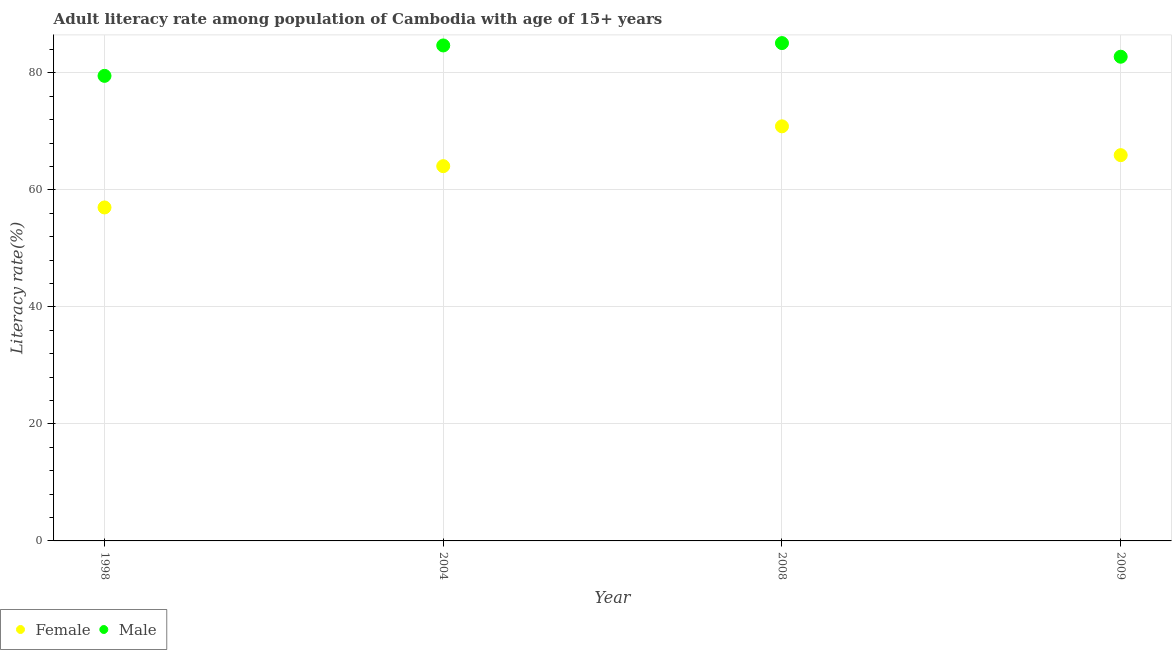How many different coloured dotlines are there?
Ensure brevity in your answer.  2. What is the male adult literacy rate in 2008?
Provide a short and direct response. 85.08. Across all years, what is the maximum male adult literacy rate?
Your answer should be very brief. 85.08. Across all years, what is the minimum male adult literacy rate?
Provide a short and direct response. 79.48. In which year was the female adult literacy rate maximum?
Offer a very short reply. 2008. In which year was the female adult literacy rate minimum?
Offer a terse response. 1998. What is the total female adult literacy rate in the graph?
Your answer should be very brief. 257.83. What is the difference between the female adult literacy rate in 1998 and that in 2008?
Keep it short and to the point. -13.87. What is the difference between the male adult literacy rate in 2004 and the female adult literacy rate in 2008?
Your response must be concise. 13.82. What is the average female adult literacy rate per year?
Make the answer very short. 64.46. In the year 2008, what is the difference between the male adult literacy rate and female adult literacy rate?
Keep it short and to the point. 14.22. In how many years, is the male adult literacy rate greater than 16 %?
Ensure brevity in your answer.  4. What is the ratio of the male adult literacy rate in 2004 to that in 2009?
Your response must be concise. 1.02. Is the female adult literacy rate in 1998 less than that in 2009?
Make the answer very short. Yes. Is the difference between the female adult literacy rate in 2004 and 2009 greater than the difference between the male adult literacy rate in 2004 and 2009?
Offer a terse response. No. What is the difference between the highest and the second highest male adult literacy rate?
Keep it short and to the point. 0.4. What is the difference between the highest and the lowest female adult literacy rate?
Your response must be concise. 13.87. In how many years, is the female adult literacy rate greater than the average female adult literacy rate taken over all years?
Offer a very short reply. 2. Is the sum of the female adult literacy rate in 1998 and 2009 greater than the maximum male adult literacy rate across all years?
Offer a very short reply. Yes. Does the female adult literacy rate monotonically increase over the years?
Offer a terse response. No. Is the male adult literacy rate strictly greater than the female adult literacy rate over the years?
Give a very brief answer. Yes. How many years are there in the graph?
Your answer should be compact. 4. What is the difference between two consecutive major ticks on the Y-axis?
Provide a short and direct response. 20. Does the graph contain any zero values?
Ensure brevity in your answer.  No. Does the graph contain grids?
Provide a short and direct response. Yes. How many legend labels are there?
Your answer should be compact. 2. What is the title of the graph?
Your answer should be very brief. Adult literacy rate among population of Cambodia with age of 15+ years. What is the label or title of the X-axis?
Offer a very short reply. Year. What is the label or title of the Y-axis?
Your answer should be very brief. Literacy rate(%). What is the Literacy rate(%) of Female in 1998?
Offer a terse response. 56.99. What is the Literacy rate(%) in Male in 1998?
Your response must be concise. 79.48. What is the Literacy rate(%) in Female in 2004?
Keep it short and to the point. 64.05. What is the Literacy rate(%) of Male in 2004?
Ensure brevity in your answer.  84.68. What is the Literacy rate(%) in Female in 2008?
Offer a terse response. 70.86. What is the Literacy rate(%) of Male in 2008?
Provide a succinct answer. 85.08. What is the Literacy rate(%) in Female in 2009?
Give a very brief answer. 65.93. What is the Literacy rate(%) in Male in 2009?
Your answer should be compact. 82.75. Across all years, what is the maximum Literacy rate(%) of Female?
Offer a terse response. 70.86. Across all years, what is the maximum Literacy rate(%) of Male?
Your response must be concise. 85.08. Across all years, what is the minimum Literacy rate(%) in Female?
Offer a terse response. 56.99. Across all years, what is the minimum Literacy rate(%) of Male?
Give a very brief answer. 79.48. What is the total Literacy rate(%) of Female in the graph?
Offer a very short reply. 257.83. What is the total Literacy rate(%) of Male in the graph?
Offer a very short reply. 332. What is the difference between the Literacy rate(%) in Female in 1998 and that in 2004?
Your response must be concise. -7.06. What is the difference between the Literacy rate(%) of Male in 1998 and that in 2004?
Your answer should be very brief. -5.2. What is the difference between the Literacy rate(%) in Female in 1998 and that in 2008?
Keep it short and to the point. -13.87. What is the difference between the Literacy rate(%) of Male in 1998 and that in 2008?
Your answer should be compact. -5.6. What is the difference between the Literacy rate(%) of Female in 1998 and that in 2009?
Your answer should be very brief. -8.94. What is the difference between the Literacy rate(%) in Male in 1998 and that in 2009?
Provide a short and direct response. -3.27. What is the difference between the Literacy rate(%) in Female in 2004 and that in 2008?
Keep it short and to the point. -6.81. What is the difference between the Literacy rate(%) in Male in 2004 and that in 2008?
Ensure brevity in your answer.  -0.4. What is the difference between the Literacy rate(%) of Female in 2004 and that in 2009?
Make the answer very short. -1.88. What is the difference between the Literacy rate(%) of Male in 2004 and that in 2009?
Keep it short and to the point. 1.93. What is the difference between the Literacy rate(%) in Female in 2008 and that in 2009?
Your answer should be very brief. 4.93. What is the difference between the Literacy rate(%) in Male in 2008 and that in 2009?
Offer a very short reply. 2.33. What is the difference between the Literacy rate(%) in Female in 1998 and the Literacy rate(%) in Male in 2004?
Ensure brevity in your answer.  -27.69. What is the difference between the Literacy rate(%) of Female in 1998 and the Literacy rate(%) of Male in 2008?
Your response must be concise. -28.09. What is the difference between the Literacy rate(%) of Female in 1998 and the Literacy rate(%) of Male in 2009?
Ensure brevity in your answer.  -25.76. What is the difference between the Literacy rate(%) in Female in 2004 and the Literacy rate(%) in Male in 2008?
Ensure brevity in your answer.  -21.03. What is the difference between the Literacy rate(%) in Female in 2004 and the Literacy rate(%) in Male in 2009?
Give a very brief answer. -18.7. What is the difference between the Literacy rate(%) of Female in 2008 and the Literacy rate(%) of Male in 2009?
Your answer should be compact. -11.89. What is the average Literacy rate(%) of Female per year?
Ensure brevity in your answer.  64.46. What is the average Literacy rate(%) in Male per year?
Provide a short and direct response. 83. In the year 1998, what is the difference between the Literacy rate(%) in Female and Literacy rate(%) in Male?
Your answer should be compact. -22.49. In the year 2004, what is the difference between the Literacy rate(%) in Female and Literacy rate(%) in Male?
Your answer should be very brief. -20.63. In the year 2008, what is the difference between the Literacy rate(%) of Female and Literacy rate(%) of Male?
Your answer should be compact. -14.22. In the year 2009, what is the difference between the Literacy rate(%) in Female and Literacy rate(%) in Male?
Your response must be concise. -16.82. What is the ratio of the Literacy rate(%) of Female in 1998 to that in 2004?
Keep it short and to the point. 0.89. What is the ratio of the Literacy rate(%) of Male in 1998 to that in 2004?
Make the answer very short. 0.94. What is the ratio of the Literacy rate(%) in Female in 1998 to that in 2008?
Ensure brevity in your answer.  0.8. What is the ratio of the Literacy rate(%) of Male in 1998 to that in 2008?
Ensure brevity in your answer.  0.93. What is the ratio of the Literacy rate(%) in Female in 1998 to that in 2009?
Offer a very short reply. 0.86. What is the ratio of the Literacy rate(%) in Male in 1998 to that in 2009?
Make the answer very short. 0.96. What is the ratio of the Literacy rate(%) in Female in 2004 to that in 2008?
Give a very brief answer. 0.9. What is the ratio of the Literacy rate(%) in Male in 2004 to that in 2008?
Give a very brief answer. 1. What is the ratio of the Literacy rate(%) in Female in 2004 to that in 2009?
Your response must be concise. 0.97. What is the ratio of the Literacy rate(%) in Male in 2004 to that in 2009?
Offer a terse response. 1.02. What is the ratio of the Literacy rate(%) in Female in 2008 to that in 2009?
Give a very brief answer. 1.07. What is the ratio of the Literacy rate(%) in Male in 2008 to that in 2009?
Provide a short and direct response. 1.03. What is the difference between the highest and the second highest Literacy rate(%) in Female?
Provide a succinct answer. 4.93. What is the difference between the highest and the second highest Literacy rate(%) in Male?
Your answer should be compact. 0.4. What is the difference between the highest and the lowest Literacy rate(%) of Female?
Your answer should be very brief. 13.87. What is the difference between the highest and the lowest Literacy rate(%) of Male?
Your answer should be very brief. 5.6. 